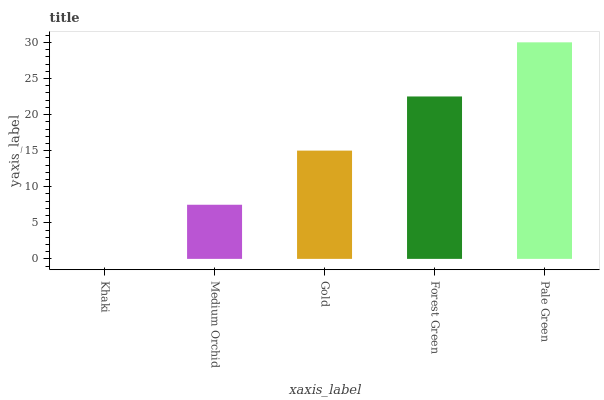Is Khaki the minimum?
Answer yes or no. Yes. Is Pale Green the maximum?
Answer yes or no. Yes. Is Medium Orchid the minimum?
Answer yes or no. No. Is Medium Orchid the maximum?
Answer yes or no. No. Is Medium Orchid greater than Khaki?
Answer yes or no. Yes. Is Khaki less than Medium Orchid?
Answer yes or no. Yes. Is Khaki greater than Medium Orchid?
Answer yes or no. No. Is Medium Orchid less than Khaki?
Answer yes or no. No. Is Gold the high median?
Answer yes or no. Yes. Is Gold the low median?
Answer yes or no. Yes. Is Khaki the high median?
Answer yes or no. No. Is Medium Orchid the low median?
Answer yes or no. No. 